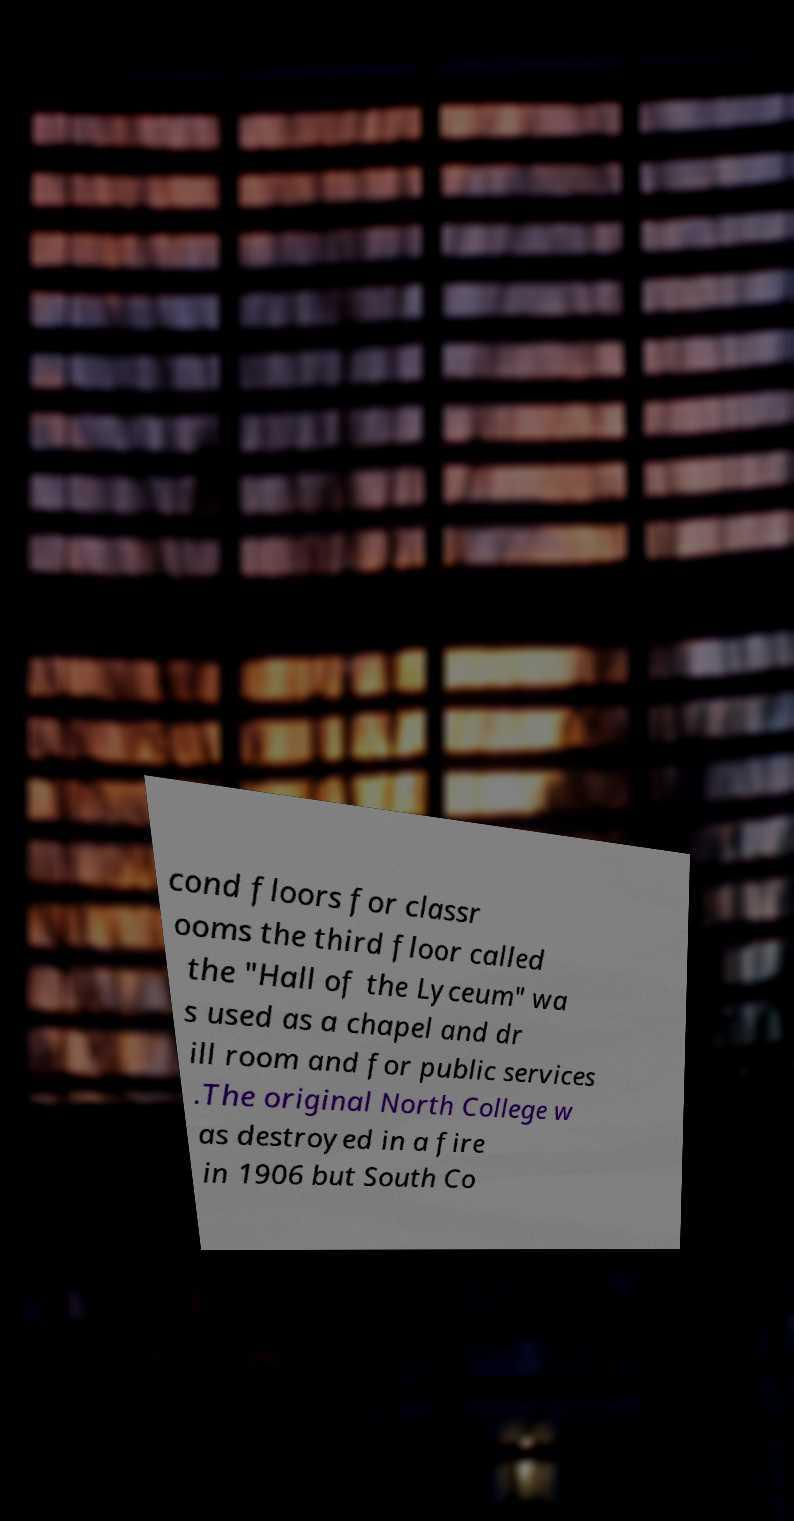There's text embedded in this image that I need extracted. Can you transcribe it verbatim? cond floors for classr ooms the third floor called the "Hall of the Lyceum" wa s used as a chapel and dr ill room and for public services .The original North College w as destroyed in a fire in 1906 but South Co 